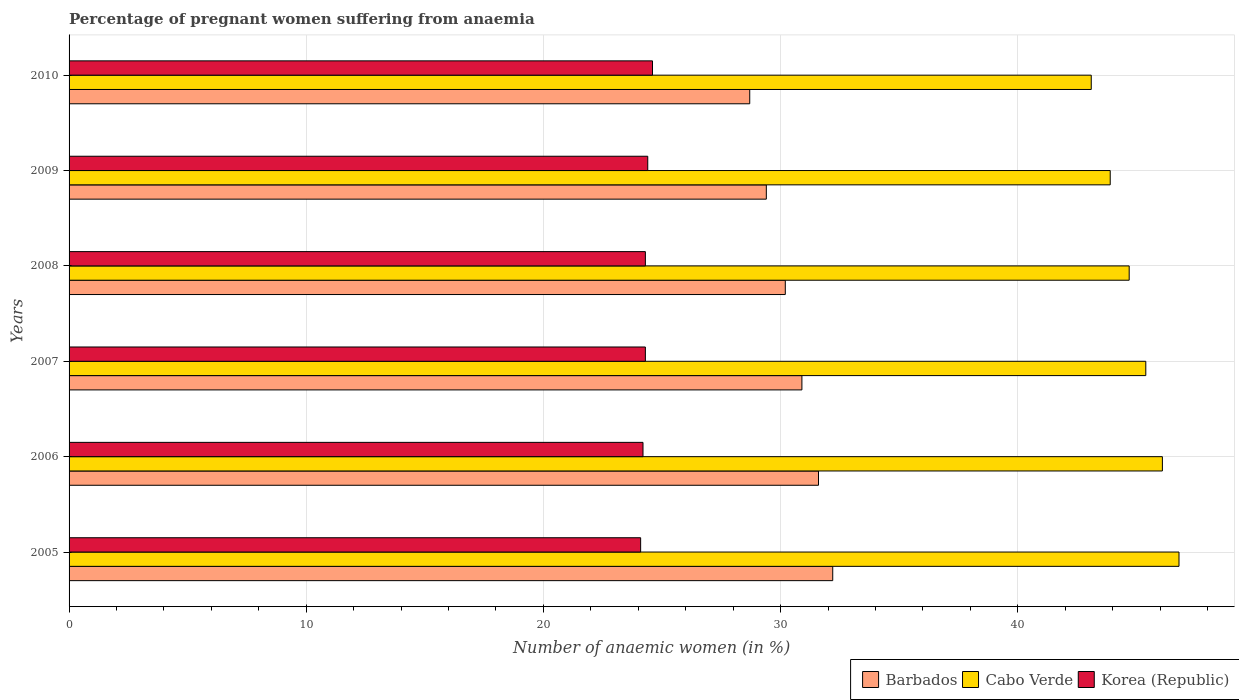Are the number of bars per tick equal to the number of legend labels?
Offer a terse response. Yes. Are the number of bars on each tick of the Y-axis equal?
Make the answer very short. Yes. How many bars are there on the 3rd tick from the top?
Provide a short and direct response. 3. How many bars are there on the 4th tick from the bottom?
Ensure brevity in your answer.  3. What is the number of anaemic women in Barbados in 2005?
Offer a very short reply. 32.2. Across all years, what is the maximum number of anaemic women in Barbados?
Make the answer very short. 32.2. Across all years, what is the minimum number of anaemic women in Barbados?
Ensure brevity in your answer.  28.7. In which year was the number of anaemic women in Barbados minimum?
Ensure brevity in your answer.  2010. What is the total number of anaemic women in Barbados in the graph?
Make the answer very short. 183. What is the difference between the number of anaemic women in Barbados in 2005 and that in 2009?
Offer a very short reply. 2.8. What is the difference between the number of anaemic women in Korea (Republic) in 2010 and the number of anaemic women in Barbados in 2008?
Give a very brief answer. -5.6. What is the average number of anaemic women in Korea (Republic) per year?
Give a very brief answer. 24.32. In the year 2007, what is the difference between the number of anaemic women in Barbados and number of anaemic women in Korea (Republic)?
Your response must be concise. 6.6. What is the ratio of the number of anaemic women in Barbados in 2005 to that in 2007?
Provide a succinct answer. 1.04. Is the number of anaemic women in Cabo Verde in 2005 less than that in 2009?
Provide a succinct answer. No. What is the difference between the highest and the second highest number of anaemic women in Cabo Verde?
Provide a short and direct response. 0.7. In how many years, is the number of anaemic women in Barbados greater than the average number of anaemic women in Barbados taken over all years?
Provide a short and direct response. 3. Is the sum of the number of anaemic women in Barbados in 2005 and 2006 greater than the maximum number of anaemic women in Korea (Republic) across all years?
Your response must be concise. Yes. What does the 2nd bar from the top in 2006 represents?
Provide a short and direct response. Cabo Verde. What does the 1st bar from the bottom in 2010 represents?
Offer a terse response. Barbados. Is it the case that in every year, the sum of the number of anaemic women in Barbados and number of anaemic women in Cabo Verde is greater than the number of anaemic women in Korea (Republic)?
Ensure brevity in your answer.  Yes. Are all the bars in the graph horizontal?
Your answer should be compact. Yes. How many years are there in the graph?
Offer a terse response. 6. What is the difference between two consecutive major ticks on the X-axis?
Keep it short and to the point. 10. Does the graph contain any zero values?
Your response must be concise. No. Does the graph contain grids?
Make the answer very short. Yes. How many legend labels are there?
Offer a very short reply. 3. How are the legend labels stacked?
Offer a very short reply. Horizontal. What is the title of the graph?
Your answer should be compact. Percentage of pregnant women suffering from anaemia. Does "Maldives" appear as one of the legend labels in the graph?
Ensure brevity in your answer.  No. What is the label or title of the X-axis?
Keep it short and to the point. Number of anaemic women (in %). What is the label or title of the Y-axis?
Provide a short and direct response. Years. What is the Number of anaemic women (in %) in Barbados in 2005?
Provide a succinct answer. 32.2. What is the Number of anaemic women (in %) in Cabo Verde in 2005?
Ensure brevity in your answer.  46.8. What is the Number of anaemic women (in %) of Korea (Republic) in 2005?
Offer a very short reply. 24.1. What is the Number of anaemic women (in %) in Barbados in 2006?
Give a very brief answer. 31.6. What is the Number of anaemic women (in %) in Cabo Verde in 2006?
Make the answer very short. 46.1. What is the Number of anaemic women (in %) in Korea (Republic) in 2006?
Your response must be concise. 24.2. What is the Number of anaemic women (in %) in Barbados in 2007?
Make the answer very short. 30.9. What is the Number of anaemic women (in %) of Cabo Verde in 2007?
Your response must be concise. 45.4. What is the Number of anaemic women (in %) of Korea (Republic) in 2007?
Keep it short and to the point. 24.3. What is the Number of anaemic women (in %) of Barbados in 2008?
Provide a short and direct response. 30.2. What is the Number of anaemic women (in %) in Cabo Verde in 2008?
Your answer should be very brief. 44.7. What is the Number of anaemic women (in %) of Korea (Republic) in 2008?
Provide a short and direct response. 24.3. What is the Number of anaemic women (in %) of Barbados in 2009?
Your answer should be compact. 29.4. What is the Number of anaemic women (in %) in Cabo Verde in 2009?
Give a very brief answer. 43.9. What is the Number of anaemic women (in %) of Korea (Republic) in 2009?
Offer a very short reply. 24.4. What is the Number of anaemic women (in %) of Barbados in 2010?
Your response must be concise. 28.7. What is the Number of anaemic women (in %) of Cabo Verde in 2010?
Your answer should be very brief. 43.1. What is the Number of anaemic women (in %) in Korea (Republic) in 2010?
Ensure brevity in your answer.  24.6. Across all years, what is the maximum Number of anaemic women (in %) in Barbados?
Provide a short and direct response. 32.2. Across all years, what is the maximum Number of anaemic women (in %) of Cabo Verde?
Offer a very short reply. 46.8. Across all years, what is the maximum Number of anaemic women (in %) in Korea (Republic)?
Give a very brief answer. 24.6. Across all years, what is the minimum Number of anaemic women (in %) of Barbados?
Offer a very short reply. 28.7. Across all years, what is the minimum Number of anaemic women (in %) of Cabo Verde?
Your answer should be compact. 43.1. Across all years, what is the minimum Number of anaemic women (in %) in Korea (Republic)?
Ensure brevity in your answer.  24.1. What is the total Number of anaemic women (in %) in Barbados in the graph?
Provide a short and direct response. 183. What is the total Number of anaemic women (in %) of Cabo Verde in the graph?
Your answer should be compact. 270. What is the total Number of anaemic women (in %) of Korea (Republic) in the graph?
Give a very brief answer. 145.9. What is the difference between the Number of anaemic women (in %) of Barbados in 2005 and that in 2006?
Provide a short and direct response. 0.6. What is the difference between the Number of anaemic women (in %) in Korea (Republic) in 2005 and that in 2006?
Ensure brevity in your answer.  -0.1. What is the difference between the Number of anaemic women (in %) of Barbados in 2005 and that in 2007?
Provide a succinct answer. 1.3. What is the difference between the Number of anaemic women (in %) in Cabo Verde in 2005 and that in 2009?
Make the answer very short. 2.9. What is the difference between the Number of anaemic women (in %) in Korea (Republic) in 2005 and that in 2010?
Provide a succinct answer. -0.5. What is the difference between the Number of anaemic women (in %) of Barbados in 2006 and that in 2007?
Offer a terse response. 0.7. What is the difference between the Number of anaemic women (in %) of Korea (Republic) in 2006 and that in 2007?
Keep it short and to the point. -0.1. What is the difference between the Number of anaemic women (in %) of Barbados in 2006 and that in 2008?
Make the answer very short. 1.4. What is the difference between the Number of anaemic women (in %) in Korea (Republic) in 2006 and that in 2008?
Your response must be concise. -0.1. What is the difference between the Number of anaemic women (in %) in Cabo Verde in 2006 and that in 2009?
Your response must be concise. 2.2. What is the difference between the Number of anaemic women (in %) of Korea (Republic) in 2006 and that in 2009?
Your response must be concise. -0.2. What is the difference between the Number of anaemic women (in %) of Cabo Verde in 2006 and that in 2010?
Provide a short and direct response. 3. What is the difference between the Number of anaemic women (in %) in Barbados in 2007 and that in 2009?
Offer a very short reply. 1.5. What is the difference between the Number of anaemic women (in %) of Barbados in 2007 and that in 2010?
Offer a terse response. 2.2. What is the difference between the Number of anaemic women (in %) of Barbados in 2008 and that in 2009?
Your response must be concise. 0.8. What is the difference between the Number of anaemic women (in %) in Cabo Verde in 2008 and that in 2009?
Provide a succinct answer. 0.8. What is the difference between the Number of anaemic women (in %) in Korea (Republic) in 2008 and that in 2009?
Provide a short and direct response. -0.1. What is the difference between the Number of anaemic women (in %) of Barbados in 2008 and that in 2010?
Offer a terse response. 1.5. What is the difference between the Number of anaemic women (in %) in Cabo Verde in 2009 and that in 2010?
Make the answer very short. 0.8. What is the difference between the Number of anaemic women (in %) of Barbados in 2005 and the Number of anaemic women (in %) of Korea (Republic) in 2006?
Provide a succinct answer. 8. What is the difference between the Number of anaemic women (in %) in Cabo Verde in 2005 and the Number of anaemic women (in %) in Korea (Republic) in 2006?
Your response must be concise. 22.6. What is the difference between the Number of anaemic women (in %) in Barbados in 2005 and the Number of anaemic women (in %) in Korea (Republic) in 2007?
Provide a succinct answer. 7.9. What is the difference between the Number of anaemic women (in %) of Barbados in 2005 and the Number of anaemic women (in %) of Cabo Verde in 2008?
Ensure brevity in your answer.  -12.5. What is the difference between the Number of anaemic women (in %) in Cabo Verde in 2005 and the Number of anaemic women (in %) in Korea (Republic) in 2009?
Keep it short and to the point. 22.4. What is the difference between the Number of anaemic women (in %) of Barbados in 2005 and the Number of anaemic women (in %) of Cabo Verde in 2010?
Keep it short and to the point. -10.9. What is the difference between the Number of anaemic women (in %) of Barbados in 2006 and the Number of anaemic women (in %) of Korea (Republic) in 2007?
Your answer should be very brief. 7.3. What is the difference between the Number of anaemic women (in %) of Cabo Verde in 2006 and the Number of anaemic women (in %) of Korea (Republic) in 2007?
Your response must be concise. 21.8. What is the difference between the Number of anaemic women (in %) in Barbados in 2006 and the Number of anaemic women (in %) in Korea (Republic) in 2008?
Give a very brief answer. 7.3. What is the difference between the Number of anaemic women (in %) in Cabo Verde in 2006 and the Number of anaemic women (in %) in Korea (Republic) in 2008?
Make the answer very short. 21.8. What is the difference between the Number of anaemic women (in %) in Barbados in 2006 and the Number of anaemic women (in %) in Cabo Verde in 2009?
Your answer should be very brief. -12.3. What is the difference between the Number of anaemic women (in %) in Barbados in 2006 and the Number of anaemic women (in %) in Korea (Republic) in 2009?
Offer a very short reply. 7.2. What is the difference between the Number of anaemic women (in %) of Cabo Verde in 2006 and the Number of anaemic women (in %) of Korea (Republic) in 2009?
Ensure brevity in your answer.  21.7. What is the difference between the Number of anaemic women (in %) in Cabo Verde in 2006 and the Number of anaemic women (in %) in Korea (Republic) in 2010?
Make the answer very short. 21.5. What is the difference between the Number of anaemic women (in %) in Barbados in 2007 and the Number of anaemic women (in %) in Korea (Republic) in 2008?
Make the answer very short. 6.6. What is the difference between the Number of anaemic women (in %) in Cabo Verde in 2007 and the Number of anaemic women (in %) in Korea (Republic) in 2008?
Provide a succinct answer. 21.1. What is the difference between the Number of anaemic women (in %) in Barbados in 2007 and the Number of anaemic women (in %) in Cabo Verde in 2009?
Keep it short and to the point. -13. What is the difference between the Number of anaemic women (in %) of Barbados in 2007 and the Number of anaemic women (in %) of Korea (Republic) in 2009?
Offer a terse response. 6.5. What is the difference between the Number of anaemic women (in %) of Barbados in 2007 and the Number of anaemic women (in %) of Cabo Verde in 2010?
Keep it short and to the point. -12.2. What is the difference between the Number of anaemic women (in %) in Cabo Verde in 2007 and the Number of anaemic women (in %) in Korea (Republic) in 2010?
Provide a short and direct response. 20.8. What is the difference between the Number of anaemic women (in %) in Barbados in 2008 and the Number of anaemic women (in %) in Cabo Verde in 2009?
Offer a terse response. -13.7. What is the difference between the Number of anaemic women (in %) of Barbados in 2008 and the Number of anaemic women (in %) of Korea (Republic) in 2009?
Offer a terse response. 5.8. What is the difference between the Number of anaemic women (in %) in Cabo Verde in 2008 and the Number of anaemic women (in %) in Korea (Republic) in 2009?
Offer a terse response. 20.3. What is the difference between the Number of anaemic women (in %) of Barbados in 2008 and the Number of anaemic women (in %) of Korea (Republic) in 2010?
Your answer should be compact. 5.6. What is the difference between the Number of anaemic women (in %) of Cabo Verde in 2008 and the Number of anaemic women (in %) of Korea (Republic) in 2010?
Provide a succinct answer. 20.1. What is the difference between the Number of anaemic women (in %) in Barbados in 2009 and the Number of anaemic women (in %) in Cabo Verde in 2010?
Keep it short and to the point. -13.7. What is the difference between the Number of anaemic women (in %) of Cabo Verde in 2009 and the Number of anaemic women (in %) of Korea (Republic) in 2010?
Ensure brevity in your answer.  19.3. What is the average Number of anaemic women (in %) in Barbados per year?
Your answer should be very brief. 30.5. What is the average Number of anaemic women (in %) of Cabo Verde per year?
Your answer should be very brief. 45. What is the average Number of anaemic women (in %) in Korea (Republic) per year?
Your response must be concise. 24.32. In the year 2005, what is the difference between the Number of anaemic women (in %) in Barbados and Number of anaemic women (in %) in Cabo Verde?
Offer a very short reply. -14.6. In the year 2005, what is the difference between the Number of anaemic women (in %) of Cabo Verde and Number of anaemic women (in %) of Korea (Republic)?
Your answer should be very brief. 22.7. In the year 2006, what is the difference between the Number of anaemic women (in %) in Cabo Verde and Number of anaemic women (in %) in Korea (Republic)?
Your answer should be compact. 21.9. In the year 2007, what is the difference between the Number of anaemic women (in %) in Barbados and Number of anaemic women (in %) in Cabo Verde?
Offer a terse response. -14.5. In the year 2007, what is the difference between the Number of anaemic women (in %) in Cabo Verde and Number of anaemic women (in %) in Korea (Republic)?
Your answer should be very brief. 21.1. In the year 2008, what is the difference between the Number of anaemic women (in %) of Barbados and Number of anaemic women (in %) of Korea (Republic)?
Your answer should be very brief. 5.9. In the year 2008, what is the difference between the Number of anaemic women (in %) of Cabo Verde and Number of anaemic women (in %) of Korea (Republic)?
Make the answer very short. 20.4. In the year 2010, what is the difference between the Number of anaemic women (in %) of Barbados and Number of anaemic women (in %) of Cabo Verde?
Provide a succinct answer. -14.4. In the year 2010, what is the difference between the Number of anaemic women (in %) of Barbados and Number of anaemic women (in %) of Korea (Republic)?
Your answer should be very brief. 4.1. In the year 2010, what is the difference between the Number of anaemic women (in %) of Cabo Verde and Number of anaemic women (in %) of Korea (Republic)?
Your response must be concise. 18.5. What is the ratio of the Number of anaemic women (in %) of Barbados in 2005 to that in 2006?
Your answer should be very brief. 1.02. What is the ratio of the Number of anaemic women (in %) in Cabo Verde in 2005 to that in 2006?
Your response must be concise. 1.02. What is the ratio of the Number of anaemic women (in %) of Barbados in 2005 to that in 2007?
Your answer should be compact. 1.04. What is the ratio of the Number of anaemic women (in %) in Cabo Verde in 2005 to that in 2007?
Your answer should be compact. 1.03. What is the ratio of the Number of anaemic women (in %) of Barbados in 2005 to that in 2008?
Make the answer very short. 1.07. What is the ratio of the Number of anaemic women (in %) of Cabo Verde in 2005 to that in 2008?
Provide a succinct answer. 1.05. What is the ratio of the Number of anaemic women (in %) in Korea (Republic) in 2005 to that in 2008?
Your answer should be compact. 0.99. What is the ratio of the Number of anaemic women (in %) in Barbados in 2005 to that in 2009?
Make the answer very short. 1.1. What is the ratio of the Number of anaemic women (in %) of Cabo Verde in 2005 to that in 2009?
Offer a very short reply. 1.07. What is the ratio of the Number of anaemic women (in %) of Korea (Republic) in 2005 to that in 2009?
Offer a very short reply. 0.99. What is the ratio of the Number of anaemic women (in %) of Barbados in 2005 to that in 2010?
Make the answer very short. 1.12. What is the ratio of the Number of anaemic women (in %) of Cabo Verde in 2005 to that in 2010?
Provide a short and direct response. 1.09. What is the ratio of the Number of anaemic women (in %) in Korea (Republic) in 2005 to that in 2010?
Provide a succinct answer. 0.98. What is the ratio of the Number of anaemic women (in %) of Barbados in 2006 to that in 2007?
Offer a terse response. 1.02. What is the ratio of the Number of anaemic women (in %) in Cabo Verde in 2006 to that in 2007?
Provide a succinct answer. 1.02. What is the ratio of the Number of anaemic women (in %) of Korea (Republic) in 2006 to that in 2007?
Make the answer very short. 1. What is the ratio of the Number of anaemic women (in %) of Barbados in 2006 to that in 2008?
Keep it short and to the point. 1.05. What is the ratio of the Number of anaemic women (in %) of Cabo Verde in 2006 to that in 2008?
Ensure brevity in your answer.  1.03. What is the ratio of the Number of anaemic women (in %) of Barbados in 2006 to that in 2009?
Make the answer very short. 1.07. What is the ratio of the Number of anaemic women (in %) of Cabo Verde in 2006 to that in 2009?
Provide a short and direct response. 1.05. What is the ratio of the Number of anaemic women (in %) of Korea (Republic) in 2006 to that in 2009?
Offer a terse response. 0.99. What is the ratio of the Number of anaemic women (in %) of Barbados in 2006 to that in 2010?
Make the answer very short. 1.1. What is the ratio of the Number of anaemic women (in %) of Cabo Verde in 2006 to that in 2010?
Your answer should be compact. 1.07. What is the ratio of the Number of anaemic women (in %) in Korea (Republic) in 2006 to that in 2010?
Offer a terse response. 0.98. What is the ratio of the Number of anaemic women (in %) in Barbados in 2007 to that in 2008?
Your answer should be very brief. 1.02. What is the ratio of the Number of anaemic women (in %) in Cabo Verde in 2007 to that in 2008?
Your answer should be very brief. 1.02. What is the ratio of the Number of anaemic women (in %) of Barbados in 2007 to that in 2009?
Offer a terse response. 1.05. What is the ratio of the Number of anaemic women (in %) in Cabo Verde in 2007 to that in 2009?
Provide a succinct answer. 1.03. What is the ratio of the Number of anaemic women (in %) of Korea (Republic) in 2007 to that in 2009?
Your answer should be compact. 1. What is the ratio of the Number of anaemic women (in %) of Barbados in 2007 to that in 2010?
Your answer should be very brief. 1.08. What is the ratio of the Number of anaemic women (in %) of Cabo Verde in 2007 to that in 2010?
Ensure brevity in your answer.  1.05. What is the ratio of the Number of anaemic women (in %) in Barbados in 2008 to that in 2009?
Make the answer very short. 1.03. What is the ratio of the Number of anaemic women (in %) of Cabo Verde in 2008 to that in 2009?
Your answer should be very brief. 1.02. What is the ratio of the Number of anaemic women (in %) of Korea (Republic) in 2008 to that in 2009?
Make the answer very short. 1. What is the ratio of the Number of anaemic women (in %) of Barbados in 2008 to that in 2010?
Your response must be concise. 1.05. What is the ratio of the Number of anaemic women (in %) in Cabo Verde in 2008 to that in 2010?
Your response must be concise. 1.04. What is the ratio of the Number of anaemic women (in %) of Korea (Republic) in 2008 to that in 2010?
Your answer should be compact. 0.99. What is the ratio of the Number of anaemic women (in %) of Barbados in 2009 to that in 2010?
Provide a succinct answer. 1.02. What is the ratio of the Number of anaemic women (in %) in Cabo Verde in 2009 to that in 2010?
Give a very brief answer. 1.02. What is the ratio of the Number of anaemic women (in %) of Korea (Republic) in 2009 to that in 2010?
Provide a short and direct response. 0.99. What is the difference between the highest and the second highest Number of anaemic women (in %) of Cabo Verde?
Your answer should be very brief. 0.7. What is the difference between the highest and the lowest Number of anaemic women (in %) of Barbados?
Provide a succinct answer. 3.5. What is the difference between the highest and the lowest Number of anaemic women (in %) of Cabo Verde?
Keep it short and to the point. 3.7. 